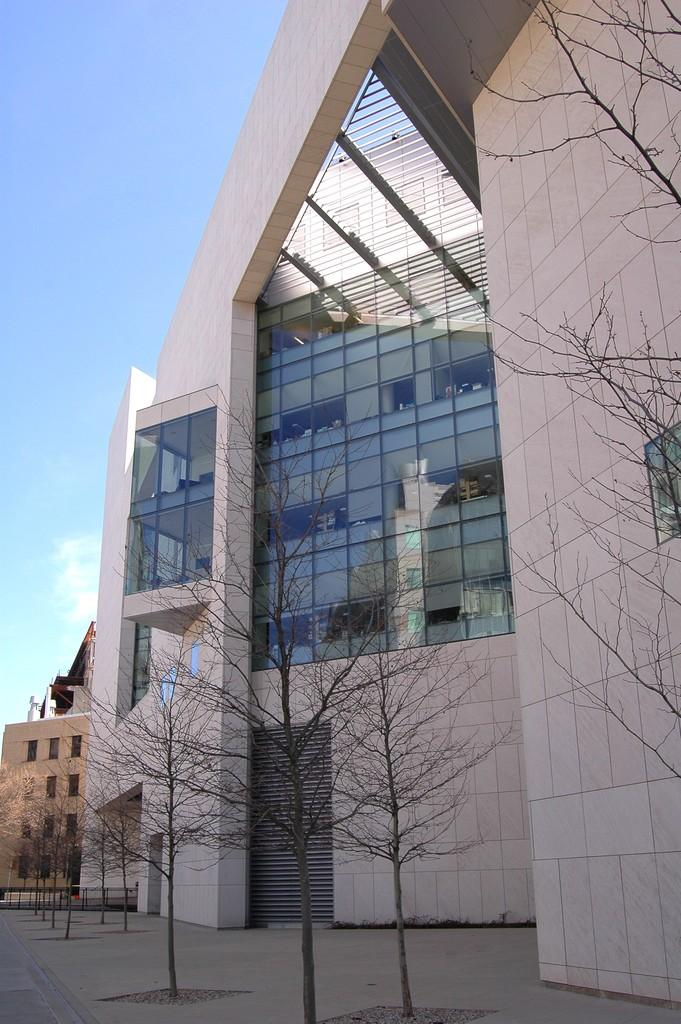What type of structures can be seen in the image? There are buildings in the image. What other natural elements are present in the image? There are trees in the image. Is there any indication of a path or road in the image? Yes, there is a path and a road in the image. What can be seen in the sky in the image? The sky is visible in the image, and there are clouds in the sky. Can you tell me how many times the comb is used in the image? There is no comb present in the image, so it cannot be used at all. What type of shoes is the grandfather wearing in the image? There is no grandfather or shoes present in the image. 